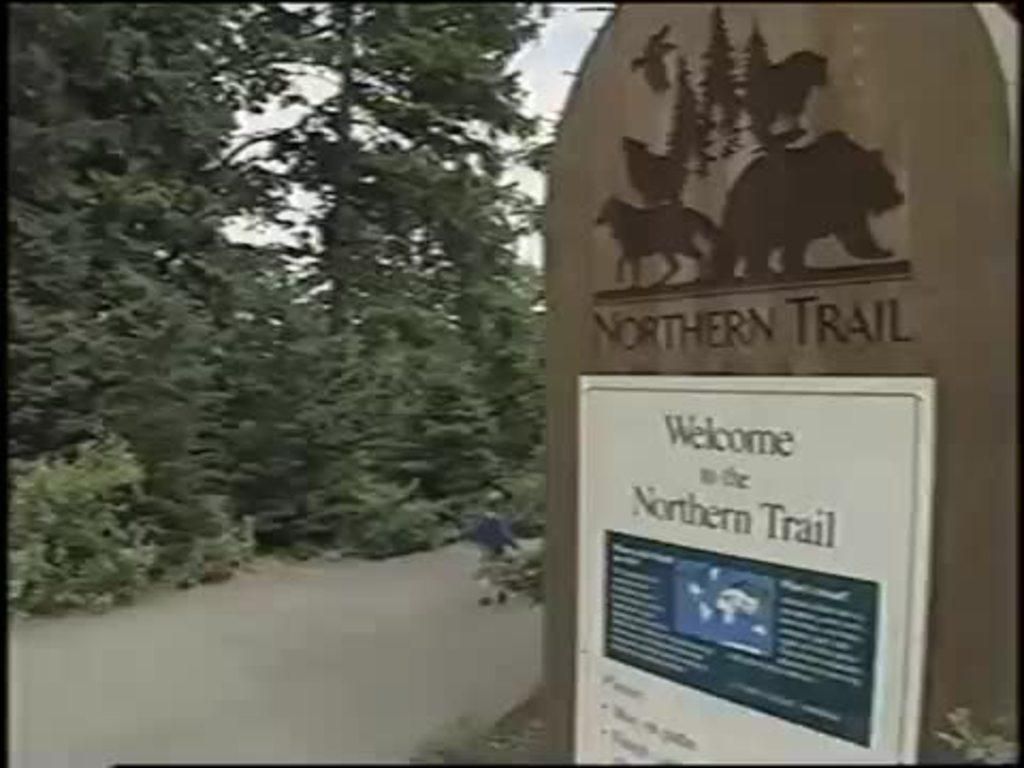<image>
Provide a brief description of the given image. A sign post for the northern trail with trees in the background. 